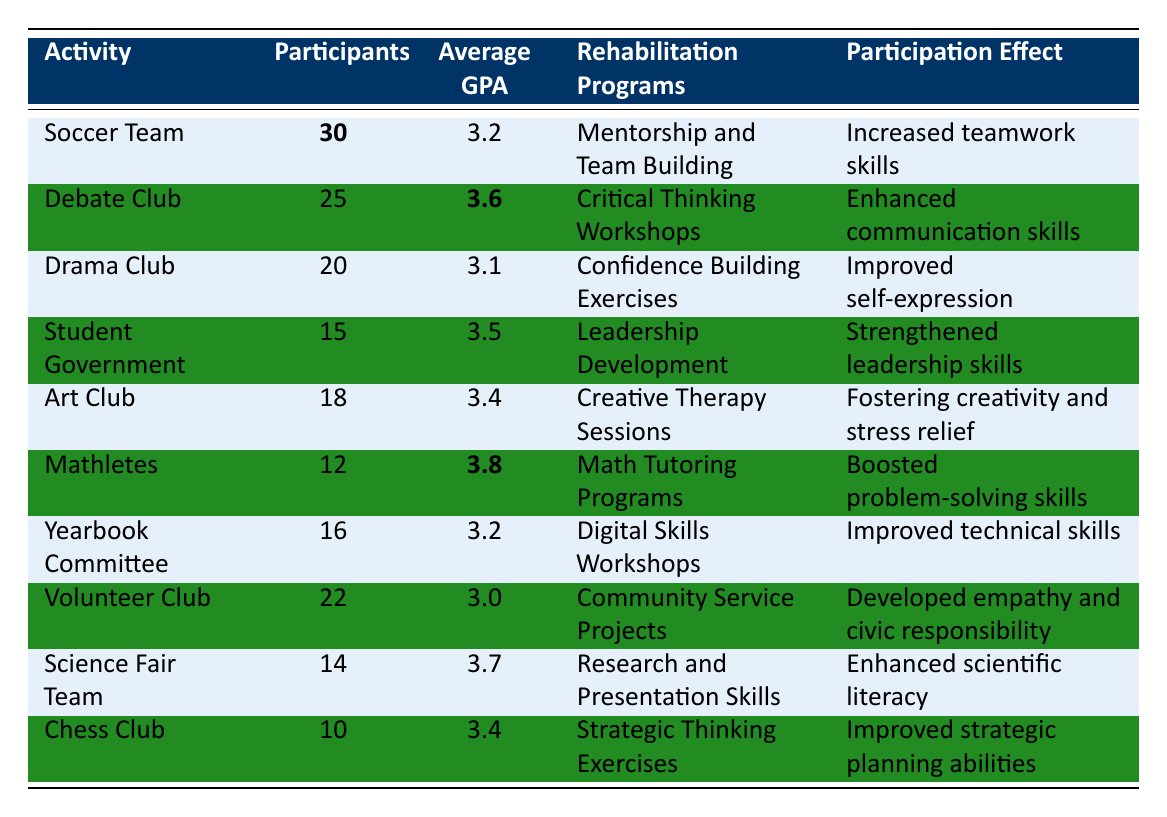What is the average GPA of the Mathletes? The average GPA for the Mathletes is listed in the table as 3.8.
Answer: 3.8 How many participants are in the Student Government? The number of participants in the Student Government is specified in the table as 15.
Answer: 15 Which extracurricular activity has the highest average GPA? The Mathletes have the highest average GPA, which is 3.8 according to the table.
Answer: Mathletes What is the average GPA of all activities? To calculate the average GPA, sum the GPAs: (3.2 + 3.6 + 3.1 + 3.5 + 3.4 + 3.8 + 3.2 + 3.0 + 3.7 + 3.4) = 34.0. There are 10 activities, so the average GPA is 34.0 / 10 = 3.4.
Answer: 3.4 What is the participation effect for the Drama Club? The participation effect for the Drama Club is "Improved self-expression" as indicated in the table.
Answer: Improved self-expression Does the Volunteer Club have a higher average GPA than the Drama Club? The average GPA of the Volunteer Club is 3.0, while the Drama Club has an average GPA of 3.1. Since 3.0 is not higher than 3.1, the answer is no.
Answer: No How many more participants are in the Soccer Team compared to the Chess Club? The Soccer Team has 30 participants and the Chess Club has 10 participants. Therefore, 30 - 10 = 20 participants more in the Soccer Team.
Answer: 20 Which two activities have the same average GPA? The Soccer Team and Yearbook Committee both have an average GPA of 3.2, as shown in the table.
Answer: Soccer Team and Yearbook Committee Is it true that all activities with rehabilitation programs have a positive participation effect? The participation effects listed indicate positive outcomes for all rehabilitation programs in the table, suggesting the statement is true.
Answer: Yes What is the difference in average GPA between the Mathletes and the Volunteer Club? The Mathletes have a GPA of 3.8 and the Volunteer Club has a GPA of 3.0. Thus, the difference is 3.8 - 3.0 = 0.8.
Answer: 0.8 